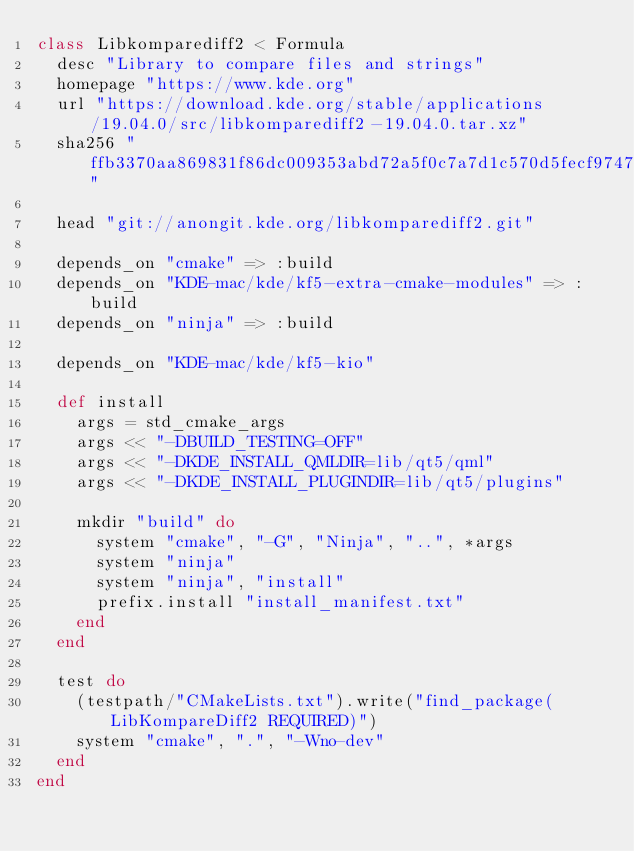<code> <loc_0><loc_0><loc_500><loc_500><_Ruby_>class Libkomparediff2 < Formula
  desc "Library to compare files and strings"
  homepage "https://www.kde.org"
  url "https://download.kde.org/stable/applications/19.04.0/src/libkomparediff2-19.04.0.tar.xz"
  sha256 "ffb3370aa869831f86dc009353abd72a5f0c7a7d1c570d5fecf9747131247464"

  head "git://anongit.kde.org/libkomparediff2.git"

  depends_on "cmake" => :build
  depends_on "KDE-mac/kde/kf5-extra-cmake-modules" => :build
  depends_on "ninja" => :build

  depends_on "KDE-mac/kde/kf5-kio"

  def install
    args = std_cmake_args
    args << "-DBUILD_TESTING=OFF"
    args << "-DKDE_INSTALL_QMLDIR=lib/qt5/qml"
    args << "-DKDE_INSTALL_PLUGINDIR=lib/qt5/plugins"

    mkdir "build" do
      system "cmake", "-G", "Ninja", "..", *args
      system "ninja"
      system "ninja", "install"
      prefix.install "install_manifest.txt"
    end
  end

  test do
    (testpath/"CMakeLists.txt").write("find_package(LibKompareDiff2 REQUIRED)")
    system "cmake", ".", "-Wno-dev"
  end
end
</code> 